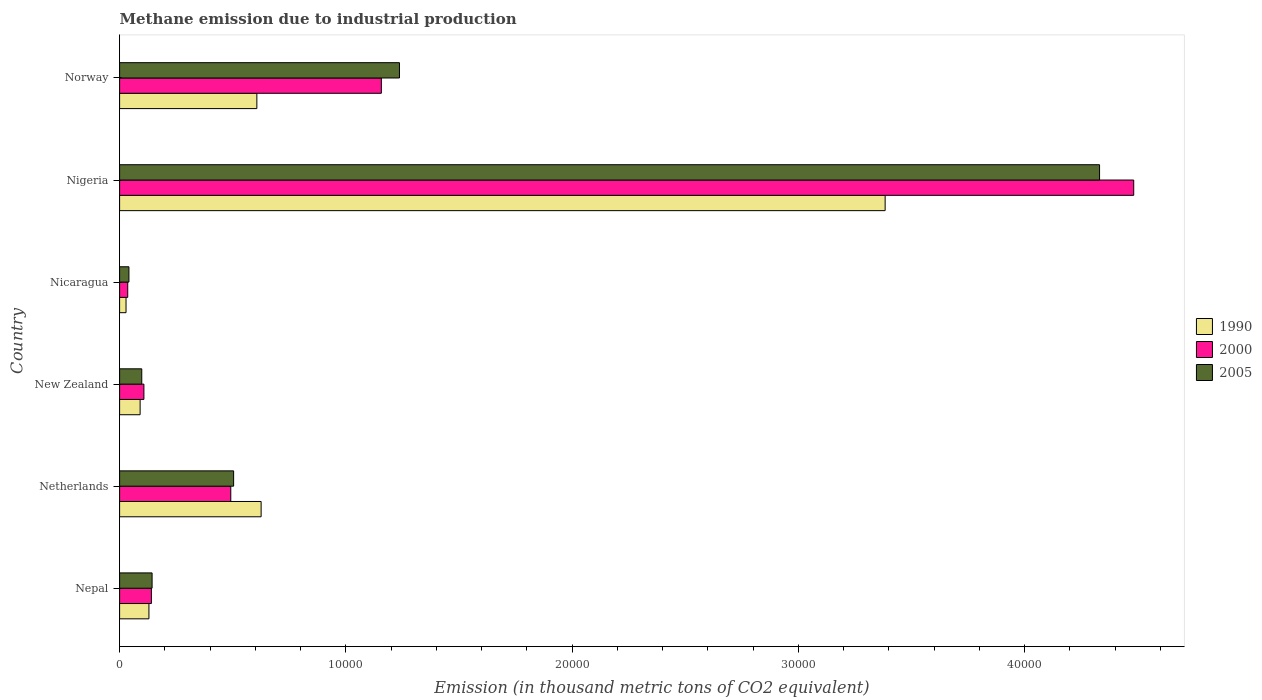How many different coloured bars are there?
Make the answer very short. 3. How many bars are there on the 5th tick from the top?
Offer a very short reply. 3. How many bars are there on the 2nd tick from the bottom?
Provide a short and direct response. 3. What is the label of the 5th group of bars from the top?
Make the answer very short. Netherlands. In how many cases, is the number of bars for a given country not equal to the number of legend labels?
Offer a terse response. 0. What is the amount of methane emitted in 2000 in Nicaragua?
Offer a very short reply. 359.5. Across all countries, what is the maximum amount of methane emitted in 2000?
Provide a succinct answer. 4.48e+04. Across all countries, what is the minimum amount of methane emitted in 2000?
Your answer should be very brief. 359.5. In which country was the amount of methane emitted in 2000 maximum?
Your answer should be very brief. Nigeria. In which country was the amount of methane emitted in 2000 minimum?
Make the answer very short. Nicaragua. What is the total amount of methane emitted in 1990 in the graph?
Your answer should be compact. 4.86e+04. What is the difference between the amount of methane emitted in 2000 in Nepal and that in Norway?
Provide a short and direct response. -1.02e+04. What is the difference between the amount of methane emitted in 1990 in Nicaragua and the amount of methane emitted in 2000 in Norway?
Provide a succinct answer. -1.13e+04. What is the average amount of methane emitted in 2000 per country?
Offer a terse response. 1.07e+04. What is the difference between the amount of methane emitted in 2000 and amount of methane emitted in 1990 in New Zealand?
Give a very brief answer. 167.2. In how many countries, is the amount of methane emitted in 1990 greater than 42000 thousand metric tons?
Offer a terse response. 0. What is the ratio of the amount of methane emitted in 2005 in Nepal to that in New Zealand?
Provide a succinct answer. 1.47. Is the amount of methane emitted in 1990 in Nicaragua less than that in Nigeria?
Give a very brief answer. Yes. Is the difference between the amount of methane emitted in 2000 in New Zealand and Nigeria greater than the difference between the amount of methane emitted in 1990 in New Zealand and Nigeria?
Provide a succinct answer. No. What is the difference between the highest and the second highest amount of methane emitted in 2005?
Your answer should be very brief. 3.09e+04. What is the difference between the highest and the lowest amount of methane emitted in 2000?
Provide a succinct answer. 4.45e+04. In how many countries, is the amount of methane emitted in 1990 greater than the average amount of methane emitted in 1990 taken over all countries?
Offer a terse response. 1. Is the sum of the amount of methane emitted in 1990 in Nepal and Nigeria greater than the maximum amount of methane emitted in 2000 across all countries?
Make the answer very short. No. Is it the case that in every country, the sum of the amount of methane emitted in 2000 and amount of methane emitted in 1990 is greater than the amount of methane emitted in 2005?
Your response must be concise. Yes. How many bars are there?
Give a very brief answer. 18. Are all the bars in the graph horizontal?
Keep it short and to the point. Yes. Are the values on the major ticks of X-axis written in scientific E-notation?
Provide a short and direct response. No. Does the graph contain any zero values?
Your answer should be very brief. No. Where does the legend appear in the graph?
Provide a short and direct response. Center right. How many legend labels are there?
Keep it short and to the point. 3. What is the title of the graph?
Ensure brevity in your answer.  Methane emission due to industrial production. What is the label or title of the X-axis?
Give a very brief answer. Emission (in thousand metric tons of CO2 equivalent). What is the Emission (in thousand metric tons of CO2 equivalent) in 1990 in Nepal?
Offer a very short reply. 1296.6. What is the Emission (in thousand metric tons of CO2 equivalent) in 2000 in Nepal?
Make the answer very short. 1405.1. What is the Emission (in thousand metric tons of CO2 equivalent) of 2005 in Nepal?
Provide a short and direct response. 1435.8. What is the Emission (in thousand metric tons of CO2 equivalent) of 1990 in Netherlands?
Make the answer very short. 6254.4. What is the Emission (in thousand metric tons of CO2 equivalent) in 2000 in Netherlands?
Ensure brevity in your answer.  4913.4. What is the Emission (in thousand metric tons of CO2 equivalent) in 2005 in Netherlands?
Keep it short and to the point. 5039.5. What is the Emission (in thousand metric tons of CO2 equivalent) of 1990 in New Zealand?
Your response must be concise. 906.8. What is the Emission (in thousand metric tons of CO2 equivalent) of 2000 in New Zealand?
Make the answer very short. 1074. What is the Emission (in thousand metric tons of CO2 equivalent) of 2005 in New Zealand?
Give a very brief answer. 979.4. What is the Emission (in thousand metric tons of CO2 equivalent) in 1990 in Nicaragua?
Ensure brevity in your answer.  284.1. What is the Emission (in thousand metric tons of CO2 equivalent) in 2000 in Nicaragua?
Your answer should be very brief. 359.5. What is the Emission (in thousand metric tons of CO2 equivalent) of 2005 in Nicaragua?
Make the answer very short. 412.7. What is the Emission (in thousand metric tons of CO2 equivalent) of 1990 in Nigeria?
Provide a succinct answer. 3.38e+04. What is the Emission (in thousand metric tons of CO2 equivalent) in 2000 in Nigeria?
Keep it short and to the point. 4.48e+04. What is the Emission (in thousand metric tons of CO2 equivalent) in 2005 in Nigeria?
Keep it short and to the point. 4.33e+04. What is the Emission (in thousand metric tons of CO2 equivalent) of 1990 in Norway?
Offer a terse response. 6065.9. What is the Emission (in thousand metric tons of CO2 equivalent) of 2000 in Norway?
Provide a short and direct response. 1.16e+04. What is the Emission (in thousand metric tons of CO2 equivalent) in 2005 in Norway?
Your response must be concise. 1.24e+04. Across all countries, what is the maximum Emission (in thousand metric tons of CO2 equivalent) of 1990?
Offer a terse response. 3.38e+04. Across all countries, what is the maximum Emission (in thousand metric tons of CO2 equivalent) in 2000?
Offer a terse response. 4.48e+04. Across all countries, what is the maximum Emission (in thousand metric tons of CO2 equivalent) of 2005?
Offer a terse response. 4.33e+04. Across all countries, what is the minimum Emission (in thousand metric tons of CO2 equivalent) of 1990?
Your answer should be compact. 284.1. Across all countries, what is the minimum Emission (in thousand metric tons of CO2 equivalent) in 2000?
Give a very brief answer. 359.5. Across all countries, what is the minimum Emission (in thousand metric tons of CO2 equivalent) in 2005?
Offer a very short reply. 412.7. What is the total Emission (in thousand metric tons of CO2 equivalent) of 1990 in the graph?
Offer a very short reply. 4.86e+04. What is the total Emission (in thousand metric tons of CO2 equivalent) of 2000 in the graph?
Provide a short and direct response. 6.41e+04. What is the total Emission (in thousand metric tons of CO2 equivalent) in 2005 in the graph?
Provide a succinct answer. 6.35e+04. What is the difference between the Emission (in thousand metric tons of CO2 equivalent) in 1990 in Nepal and that in Netherlands?
Keep it short and to the point. -4957.8. What is the difference between the Emission (in thousand metric tons of CO2 equivalent) in 2000 in Nepal and that in Netherlands?
Keep it short and to the point. -3508.3. What is the difference between the Emission (in thousand metric tons of CO2 equivalent) in 2005 in Nepal and that in Netherlands?
Provide a short and direct response. -3603.7. What is the difference between the Emission (in thousand metric tons of CO2 equivalent) of 1990 in Nepal and that in New Zealand?
Give a very brief answer. 389.8. What is the difference between the Emission (in thousand metric tons of CO2 equivalent) of 2000 in Nepal and that in New Zealand?
Your answer should be compact. 331.1. What is the difference between the Emission (in thousand metric tons of CO2 equivalent) of 2005 in Nepal and that in New Zealand?
Your answer should be very brief. 456.4. What is the difference between the Emission (in thousand metric tons of CO2 equivalent) of 1990 in Nepal and that in Nicaragua?
Give a very brief answer. 1012.5. What is the difference between the Emission (in thousand metric tons of CO2 equivalent) in 2000 in Nepal and that in Nicaragua?
Your answer should be very brief. 1045.6. What is the difference between the Emission (in thousand metric tons of CO2 equivalent) in 2005 in Nepal and that in Nicaragua?
Keep it short and to the point. 1023.1. What is the difference between the Emission (in thousand metric tons of CO2 equivalent) in 1990 in Nepal and that in Nigeria?
Offer a very short reply. -3.25e+04. What is the difference between the Emission (in thousand metric tons of CO2 equivalent) of 2000 in Nepal and that in Nigeria?
Provide a succinct answer. -4.34e+04. What is the difference between the Emission (in thousand metric tons of CO2 equivalent) of 2005 in Nepal and that in Nigeria?
Provide a short and direct response. -4.19e+04. What is the difference between the Emission (in thousand metric tons of CO2 equivalent) in 1990 in Nepal and that in Norway?
Provide a succinct answer. -4769.3. What is the difference between the Emission (in thousand metric tons of CO2 equivalent) of 2000 in Nepal and that in Norway?
Provide a short and direct response. -1.02e+04. What is the difference between the Emission (in thousand metric tons of CO2 equivalent) of 2005 in Nepal and that in Norway?
Your answer should be very brief. -1.09e+04. What is the difference between the Emission (in thousand metric tons of CO2 equivalent) in 1990 in Netherlands and that in New Zealand?
Provide a short and direct response. 5347.6. What is the difference between the Emission (in thousand metric tons of CO2 equivalent) of 2000 in Netherlands and that in New Zealand?
Ensure brevity in your answer.  3839.4. What is the difference between the Emission (in thousand metric tons of CO2 equivalent) of 2005 in Netherlands and that in New Zealand?
Provide a short and direct response. 4060.1. What is the difference between the Emission (in thousand metric tons of CO2 equivalent) in 1990 in Netherlands and that in Nicaragua?
Keep it short and to the point. 5970.3. What is the difference between the Emission (in thousand metric tons of CO2 equivalent) in 2000 in Netherlands and that in Nicaragua?
Your answer should be very brief. 4553.9. What is the difference between the Emission (in thousand metric tons of CO2 equivalent) in 2005 in Netherlands and that in Nicaragua?
Make the answer very short. 4626.8. What is the difference between the Emission (in thousand metric tons of CO2 equivalent) of 1990 in Netherlands and that in Nigeria?
Your answer should be very brief. -2.76e+04. What is the difference between the Emission (in thousand metric tons of CO2 equivalent) of 2000 in Netherlands and that in Nigeria?
Give a very brief answer. -3.99e+04. What is the difference between the Emission (in thousand metric tons of CO2 equivalent) in 2005 in Netherlands and that in Nigeria?
Offer a terse response. -3.83e+04. What is the difference between the Emission (in thousand metric tons of CO2 equivalent) of 1990 in Netherlands and that in Norway?
Ensure brevity in your answer.  188.5. What is the difference between the Emission (in thousand metric tons of CO2 equivalent) of 2000 in Netherlands and that in Norway?
Ensure brevity in your answer.  -6654.4. What is the difference between the Emission (in thousand metric tons of CO2 equivalent) in 2005 in Netherlands and that in Norway?
Your answer should be compact. -7329.3. What is the difference between the Emission (in thousand metric tons of CO2 equivalent) in 1990 in New Zealand and that in Nicaragua?
Your answer should be compact. 622.7. What is the difference between the Emission (in thousand metric tons of CO2 equivalent) of 2000 in New Zealand and that in Nicaragua?
Offer a very short reply. 714.5. What is the difference between the Emission (in thousand metric tons of CO2 equivalent) of 2005 in New Zealand and that in Nicaragua?
Provide a succinct answer. 566.7. What is the difference between the Emission (in thousand metric tons of CO2 equivalent) of 1990 in New Zealand and that in Nigeria?
Keep it short and to the point. -3.29e+04. What is the difference between the Emission (in thousand metric tons of CO2 equivalent) of 2000 in New Zealand and that in Nigeria?
Your answer should be compact. -4.37e+04. What is the difference between the Emission (in thousand metric tons of CO2 equivalent) of 2005 in New Zealand and that in Nigeria?
Make the answer very short. -4.23e+04. What is the difference between the Emission (in thousand metric tons of CO2 equivalent) in 1990 in New Zealand and that in Norway?
Offer a terse response. -5159.1. What is the difference between the Emission (in thousand metric tons of CO2 equivalent) in 2000 in New Zealand and that in Norway?
Your answer should be very brief. -1.05e+04. What is the difference between the Emission (in thousand metric tons of CO2 equivalent) in 2005 in New Zealand and that in Norway?
Offer a terse response. -1.14e+04. What is the difference between the Emission (in thousand metric tons of CO2 equivalent) of 1990 in Nicaragua and that in Nigeria?
Offer a terse response. -3.35e+04. What is the difference between the Emission (in thousand metric tons of CO2 equivalent) in 2000 in Nicaragua and that in Nigeria?
Offer a terse response. -4.45e+04. What is the difference between the Emission (in thousand metric tons of CO2 equivalent) of 2005 in Nicaragua and that in Nigeria?
Make the answer very short. -4.29e+04. What is the difference between the Emission (in thousand metric tons of CO2 equivalent) of 1990 in Nicaragua and that in Norway?
Provide a succinct answer. -5781.8. What is the difference between the Emission (in thousand metric tons of CO2 equivalent) in 2000 in Nicaragua and that in Norway?
Provide a short and direct response. -1.12e+04. What is the difference between the Emission (in thousand metric tons of CO2 equivalent) of 2005 in Nicaragua and that in Norway?
Make the answer very short. -1.20e+04. What is the difference between the Emission (in thousand metric tons of CO2 equivalent) in 1990 in Nigeria and that in Norway?
Keep it short and to the point. 2.78e+04. What is the difference between the Emission (in thousand metric tons of CO2 equivalent) of 2000 in Nigeria and that in Norway?
Provide a succinct answer. 3.33e+04. What is the difference between the Emission (in thousand metric tons of CO2 equivalent) in 2005 in Nigeria and that in Norway?
Ensure brevity in your answer.  3.09e+04. What is the difference between the Emission (in thousand metric tons of CO2 equivalent) of 1990 in Nepal and the Emission (in thousand metric tons of CO2 equivalent) of 2000 in Netherlands?
Offer a terse response. -3616.8. What is the difference between the Emission (in thousand metric tons of CO2 equivalent) in 1990 in Nepal and the Emission (in thousand metric tons of CO2 equivalent) in 2005 in Netherlands?
Offer a terse response. -3742.9. What is the difference between the Emission (in thousand metric tons of CO2 equivalent) in 2000 in Nepal and the Emission (in thousand metric tons of CO2 equivalent) in 2005 in Netherlands?
Offer a very short reply. -3634.4. What is the difference between the Emission (in thousand metric tons of CO2 equivalent) in 1990 in Nepal and the Emission (in thousand metric tons of CO2 equivalent) in 2000 in New Zealand?
Give a very brief answer. 222.6. What is the difference between the Emission (in thousand metric tons of CO2 equivalent) in 1990 in Nepal and the Emission (in thousand metric tons of CO2 equivalent) in 2005 in New Zealand?
Ensure brevity in your answer.  317.2. What is the difference between the Emission (in thousand metric tons of CO2 equivalent) in 2000 in Nepal and the Emission (in thousand metric tons of CO2 equivalent) in 2005 in New Zealand?
Your response must be concise. 425.7. What is the difference between the Emission (in thousand metric tons of CO2 equivalent) in 1990 in Nepal and the Emission (in thousand metric tons of CO2 equivalent) in 2000 in Nicaragua?
Offer a very short reply. 937.1. What is the difference between the Emission (in thousand metric tons of CO2 equivalent) of 1990 in Nepal and the Emission (in thousand metric tons of CO2 equivalent) of 2005 in Nicaragua?
Your response must be concise. 883.9. What is the difference between the Emission (in thousand metric tons of CO2 equivalent) of 2000 in Nepal and the Emission (in thousand metric tons of CO2 equivalent) of 2005 in Nicaragua?
Your answer should be compact. 992.4. What is the difference between the Emission (in thousand metric tons of CO2 equivalent) of 1990 in Nepal and the Emission (in thousand metric tons of CO2 equivalent) of 2000 in Nigeria?
Keep it short and to the point. -4.35e+04. What is the difference between the Emission (in thousand metric tons of CO2 equivalent) in 1990 in Nepal and the Emission (in thousand metric tons of CO2 equivalent) in 2005 in Nigeria?
Your response must be concise. -4.20e+04. What is the difference between the Emission (in thousand metric tons of CO2 equivalent) of 2000 in Nepal and the Emission (in thousand metric tons of CO2 equivalent) of 2005 in Nigeria?
Keep it short and to the point. -4.19e+04. What is the difference between the Emission (in thousand metric tons of CO2 equivalent) in 1990 in Nepal and the Emission (in thousand metric tons of CO2 equivalent) in 2000 in Norway?
Make the answer very short. -1.03e+04. What is the difference between the Emission (in thousand metric tons of CO2 equivalent) of 1990 in Nepal and the Emission (in thousand metric tons of CO2 equivalent) of 2005 in Norway?
Your response must be concise. -1.11e+04. What is the difference between the Emission (in thousand metric tons of CO2 equivalent) of 2000 in Nepal and the Emission (in thousand metric tons of CO2 equivalent) of 2005 in Norway?
Give a very brief answer. -1.10e+04. What is the difference between the Emission (in thousand metric tons of CO2 equivalent) in 1990 in Netherlands and the Emission (in thousand metric tons of CO2 equivalent) in 2000 in New Zealand?
Your response must be concise. 5180.4. What is the difference between the Emission (in thousand metric tons of CO2 equivalent) of 1990 in Netherlands and the Emission (in thousand metric tons of CO2 equivalent) of 2005 in New Zealand?
Provide a short and direct response. 5275. What is the difference between the Emission (in thousand metric tons of CO2 equivalent) of 2000 in Netherlands and the Emission (in thousand metric tons of CO2 equivalent) of 2005 in New Zealand?
Give a very brief answer. 3934. What is the difference between the Emission (in thousand metric tons of CO2 equivalent) of 1990 in Netherlands and the Emission (in thousand metric tons of CO2 equivalent) of 2000 in Nicaragua?
Your answer should be very brief. 5894.9. What is the difference between the Emission (in thousand metric tons of CO2 equivalent) of 1990 in Netherlands and the Emission (in thousand metric tons of CO2 equivalent) of 2005 in Nicaragua?
Ensure brevity in your answer.  5841.7. What is the difference between the Emission (in thousand metric tons of CO2 equivalent) of 2000 in Netherlands and the Emission (in thousand metric tons of CO2 equivalent) of 2005 in Nicaragua?
Your response must be concise. 4500.7. What is the difference between the Emission (in thousand metric tons of CO2 equivalent) in 1990 in Netherlands and the Emission (in thousand metric tons of CO2 equivalent) in 2000 in Nigeria?
Your answer should be very brief. -3.86e+04. What is the difference between the Emission (in thousand metric tons of CO2 equivalent) in 1990 in Netherlands and the Emission (in thousand metric tons of CO2 equivalent) in 2005 in Nigeria?
Make the answer very short. -3.71e+04. What is the difference between the Emission (in thousand metric tons of CO2 equivalent) in 2000 in Netherlands and the Emission (in thousand metric tons of CO2 equivalent) in 2005 in Nigeria?
Ensure brevity in your answer.  -3.84e+04. What is the difference between the Emission (in thousand metric tons of CO2 equivalent) of 1990 in Netherlands and the Emission (in thousand metric tons of CO2 equivalent) of 2000 in Norway?
Your answer should be very brief. -5313.4. What is the difference between the Emission (in thousand metric tons of CO2 equivalent) in 1990 in Netherlands and the Emission (in thousand metric tons of CO2 equivalent) in 2005 in Norway?
Your answer should be compact. -6114.4. What is the difference between the Emission (in thousand metric tons of CO2 equivalent) in 2000 in Netherlands and the Emission (in thousand metric tons of CO2 equivalent) in 2005 in Norway?
Keep it short and to the point. -7455.4. What is the difference between the Emission (in thousand metric tons of CO2 equivalent) in 1990 in New Zealand and the Emission (in thousand metric tons of CO2 equivalent) in 2000 in Nicaragua?
Give a very brief answer. 547.3. What is the difference between the Emission (in thousand metric tons of CO2 equivalent) of 1990 in New Zealand and the Emission (in thousand metric tons of CO2 equivalent) of 2005 in Nicaragua?
Offer a terse response. 494.1. What is the difference between the Emission (in thousand metric tons of CO2 equivalent) of 2000 in New Zealand and the Emission (in thousand metric tons of CO2 equivalent) of 2005 in Nicaragua?
Provide a succinct answer. 661.3. What is the difference between the Emission (in thousand metric tons of CO2 equivalent) of 1990 in New Zealand and the Emission (in thousand metric tons of CO2 equivalent) of 2000 in Nigeria?
Offer a very short reply. -4.39e+04. What is the difference between the Emission (in thousand metric tons of CO2 equivalent) of 1990 in New Zealand and the Emission (in thousand metric tons of CO2 equivalent) of 2005 in Nigeria?
Make the answer very short. -4.24e+04. What is the difference between the Emission (in thousand metric tons of CO2 equivalent) of 2000 in New Zealand and the Emission (in thousand metric tons of CO2 equivalent) of 2005 in Nigeria?
Your answer should be very brief. -4.22e+04. What is the difference between the Emission (in thousand metric tons of CO2 equivalent) of 1990 in New Zealand and the Emission (in thousand metric tons of CO2 equivalent) of 2000 in Norway?
Your response must be concise. -1.07e+04. What is the difference between the Emission (in thousand metric tons of CO2 equivalent) of 1990 in New Zealand and the Emission (in thousand metric tons of CO2 equivalent) of 2005 in Norway?
Keep it short and to the point. -1.15e+04. What is the difference between the Emission (in thousand metric tons of CO2 equivalent) in 2000 in New Zealand and the Emission (in thousand metric tons of CO2 equivalent) in 2005 in Norway?
Your answer should be very brief. -1.13e+04. What is the difference between the Emission (in thousand metric tons of CO2 equivalent) of 1990 in Nicaragua and the Emission (in thousand metric tons of CO2 equivalent) of 2000 in Nigeria?
Provide a short and direct response. -4.45e+04. What is the difference between the Emission (in thousand metric tons of CO2 equivalent) of 1990 in Nicaragua and the Emission (in thousand metric tons of CO2 equivalent) of 2005 in Nigeria?
Your answer should be compact. -4.30e+04. What is the difference between the Emission (in thousand metric tons of CO2 equivalent) of 2000 in Nicaragua and the Emission (in thousand metric tons of CO2 equivalent) of 2005 in Nigeria?
Provide a succinct answer. -4.30e+04. What is the difference between the Emission (in thousand metric tons of CO2 equivalent) in 1990 in Nicaragua and the Emission (in thousand metric tons of CO2 equivalent) in 2000 in Norway?
Offer a very short reply. -1.13e+04. What is the difference between the Emission (in thousand metric tons of CO2 equivalent) in 1990 in Nicaragua and the Emission (in thousand metric tons of CO2 equivalent) in 2005 in Norway?
Give a very brief answer. -1.21e+04. What is the difference between the Emission (in thousand metric tons of CO2 equivalent) of 2000 in Nicaragua and the Emission (in thousand metric tons of CO2 equivalent) of 2005 in Norway?
Offer a very short reply. -1.20e+04. What is the difference between the Emission (in thousand metric tons of CO2 equivalent) in 1990 in Nigeria and the Emission (in thousand metric tons of CO2 equivalent) in 2000 in Norway?
Make the answer very short. 2.23e+04. What is the difference between the Emission (in thousand metric tons of CO2 equivalent) in 1990 in Nigeria and the Emission (in thousand metric tons of CO2 equivalent) in 2005 in Norway?
Provide a short and direct response. 2.15e+04. What is the difference between the Emission (in thousand metric tons of CO2 equivalent) in 2000 in Nigeria and the Emission (in thousand metric tons of CO2 equivalent) in 2005 in Norway?
Your answer should be compact. 3.25e+04. What is the average Emission (in thousand metric tons of CO2 equivalent) of 1990 per country?
Make the answer very short. 8106.88. What is the average Emission (in thousand metric tons of CO2 equivalent) in 2000 per country?
Provide a short and direct response. 1.07e+04. What is the average Emission (in thousand metric tons of CO2 equivalent) in 2005 per country?
Your answer should be compact. 1.06e+04. What is the difference between the Emission (in thousand metric tons of CO2 equivalent) in 1990 and Emission (in thousand metric tons of CO2 equivalent) in 2000 in Nepal?
Provide a short and direct response. -108.5. What is the difference between the Emission (in thousand metric tons of CO2 equivalent) in 1990 and Emission (in thousand metric tons of CO2 equivalent) in 2005 in Nepal?
Provide a short and direct response. -139.2. What is the difference between the Emission (in thousand metric tons of CO2 equivalent) of 2000 and Emission (in thousand metric tons of CO2 equivalent) of 2005 in Nepal?
Keep it short and to the point. -30.7. What is the difference between the Emission (in thousand metric tons of CO2 equivalent) in 1990 and Emission (in thousand metric tons of CO2 equivalent) in 2000 in Netherlands?
Provide a succinct answer. 1341. What is the difference between the Emission (in thousand metric tons of CO2 equivalent) of 1990 and Emission (in thousand metric tons of CO2 equivalent) of 2005 in Netherlands?
Offer a terse response. 1214.9. What is the difference between the Emission (in thousand metric tons of CO2 equivalent) in 2000 and Emission (in thousand metric tons of CO2 equivalent) in 2005 in Netherlands?
Give a very brief answer. -126.1. What is the difference between the Emission (in thousand metric tons of CO2 equivalent) in 1990 and Emission (in thousand metric tons of CO2 equivalent) in 2000 in New Zealand?
Provide a short and direct response. -167.2. What is the difference between the Emission (in thousand metric tons of CO2 equivalent) in 1990 and Emission (in thousand metric tons of CO2 equivalent) in 2005 in New Zealand?
Ensure brevity in your answer.  -72.6. What is the difference between the Emission (in thousand metric tons of CO2 equivalent) in 2000 and Emission (in thousand metric tons of CO2 equivalent) in 2005 in New Zealand?
Keep it short and to the point. 94.6. What is the difference between the Emission (in thousand metric tons of CO2 equivalent) in 1990 and Emission (in thousand metric tons of CO2 equivalent) in 2000 in Nicaragua?
Make the answer very short. -75.4. What is the difference between the Emission (in thousand metric tons of CO2 equivalent) in 1990 and Emission (in thousand metric tons of CO2 equivalent) in 2005 in Nicaragua?
Your response must be concise. -128.6. What is the difference between the Emission (in thousand metric tons of CO2 equivalent) of 2000 and Emission (in thousand metric tons of CO2 equivalent) of 2005 in Nicaragua?
Provide a succinct answer. -53.2. What is the difference between the Emission (in thousand metric tons of CO2 equivalent) of 1990 and Emission (in thousand metric tons of CO2 equivalent) of 2000 in Nigeria?
Make the answer very short. -1.10e+04. What is the difference between the Emission (in thousand metric tons of CO2 equivalent) of 1990 and Emission (in thousand metric tons of CO2 equivalent) of 2005 in Nigeria?
Your answer should be very brief. -9476.4. What is the difference between the Emission (in thousand metric tons of CO2 equivalent) in 2000 and Emission (in thousand metric tons of CO2 equivalent) in 2005 in Nigeria?
Provide a short and direct response. 1509.9. What is the difference between the Emission (in thousand metric tons of CO2 equivalent) in 1990 and Emission (in thousand metric tons of CO2 equivalent) in 2000 in Norway?
Offer a very short reply. -5501.9. What is the difference between the Emission (in thousand metric tons of CO2 equivalent) of 1990 and Emission (in thousand metric tons of CO2 equivalent) of 2005 in Norway?
Give a very brief answer. -6302.9. What is the difference between the Emission (in thousand metric tons of CO2 equivalent) of 2000 and Emission (in thousand metric tons of CO2 equivalent) of 2005 in Norway?
Your response must be concise. -801. What is the ratio of the Emission (in thousand metric tons of CO2 equivalent) in 1990 in Nepal to that in Netherlands?
Give a very brief answer. 0.21. What is the ratio of the Emission (in thousand metric tons of CO2 equivalent) in 2000 in Nepal to that in Netherlands?
Offer a very short reply. 0.29. What is the ratio of the Emission (in thousand metric tons of CO2 equivalent) in 2005 in Nepal to that in Netherlands?
Your answer should be very brief. 0.28. What is the ratio of the Emission (in thousand metric tons of CO2 equivalent) in 1990 in Nepal to that in New Zealand?
Your answer should be compact. 1.43. What is the ratio of the Emission (in thousand metric tons of CO2 equivalent) in 2000 in Nepal to that in New Zealand?
Offer a very short reply. 1.31. What is the ratio of the Emission (in thousand metric tons of CO2 equivalent) of 2005 in Nepal to that in New Zealand?
Your answer should be compact. 1.47. What is the ratio of the Emission (in thousand metric tons of CO2 equivalent) of 1990 in Nepal to that in Nicaragua?
Provide a short and direct response. 4.56. What is the ratio of the Emission (in thousand metric tons of CO2 equivalent) in 2000 in Nepal to that in Nicaragua?
Provide a succinct answer. 3.91. What is the ratio of the Emission (in thousand metric tons of CO2 equivalent) in 2005 in Nepal to that in Nicaragua?
Your response must be concise. 3.48. What is the ratio of the Emission (in thousand metric tons of CO2 equivalent) in 1990 in Nepal to that in Nigeria?
Offer a terse response. 0.04. What is the ratio of the Emission (in thousand metric tons of CO2 equivalent) in 2000 in Nepal to that in Nigeria?
Your answer should be compact. 0.03. What is the ratio of the Emission (in thousand metric tons of CO2 equivalent) in 2005 in Nepal to that in Nigeria?
Offer a very short reply. 0.03. What is the ratio of the Emission (in thousand metric tons of CO2 equivalent) in 1990 in Nepal to that in Norway?
Keep it short and to the point. 0.21. What is the ratio of the Emission (in thousand metric tons of CO2 equivalent) in 2000 in Nepal to that in Norway?
Make the answer very short. 0.12. What is the ratio of the Emission (in thousand metric tons of CO2 equivalent) of 2005 in Nepal to that in Norway?
Keep it short and to the point. 0.12. What is the ratio of the Emission (in thousand metric tons of CO2 equivalent) of 1990 in Netherlands to that in New Zealand?
Make the answer very short. 6.9. What is the ratio of the Emission (in thousand metric tons of CO2 equivalent) in 2000 in Netherlands to that in New Zealand?
Your answer should be compact. 4.57. What is the ratio of the Emission (in thousand metric tons of CO2 equivalent) in 2005 in Netherlands to that in New Zealand?
Provide a succinct answer. 5.15. What is the ratio of the Emission (in thousand metric tons of CO2 equivalent) in 1990 in Netherlands to that in Nicaragua?
Keep it short and to the point. 22.01. What is the ratio of the Emission (in thousand metric tons of CO2 equivalent) in 2000 in Netherlands to that in Nicaragua?
Ensure brevity in your answer.  13.67. What is the ratio of the Emission (in thousand metric tons of CO2 equivalent) in 2005 in Netherlands to that in Nicaragua?
Provide a succinct answer. 12.21. What is the ratio of the Emission (in thousand metric tons of CO2 equivalent) in 1990 in Netherlands to that in Nigeria?
Your answer should be very brief. 0.18. What is the ratio of the Emission (in thousand metric tons of CO2 equivalent) in 2000 in Netherlands to that in Nigeria?
Offer a very short reply. 0.11. What is the ratio of the Emission (in thousand metric tons of CO2 equivalent) of 2005 in Netherlands to that in Nigeria?
Offer a very short reply. 0.12. What is the ratio of the Emission (in thousand metric tons of CO2 equivalent) in 1990 in Netherlands to that in Norway?
Your answer should be compact. 1.03. What is the ratio of the Emission (in thousand metric tons of CO2 equivalent) in 2000 in Netherlands to that in Norway?
Ensure brevity in your answer.  0.42. What is the ratio of the Emission (in thousand metric tons of CO2 equivalent) of 2005 in Netherlands to that in Norway?
Ensure brevity in your answer.  0.41. What is the ratio of the Emission (in thousand metric tons of CO2 equivalent) of 1990 in New Zealand to that in Nicaragua?
Offer a very short reply. 3.19. What is the ratio of the Emission (in thousand metric tons of CO2 equivalent) in 2000 in New Zealand to that in Nicaragua?
Your answer should be very brief. 2.99. What is the ratio of the Emission (in thousand metric tons of CO2 equivalent) of 2005 in New Zealand to that in Nicaragua?
Ensure brevity in your answer.  2.37. What is the ratio of the Emission (in thousand metric tons of CO2 equivalent) in 1990 in New Zealand to that in Nigeria?
Keep it short and to the point. 0.03. What is the ratio of the Emission (in thousand metric tons of CO2 equivalent) of 2000 in New Zealand to that in Nigeria?
Give a very brief answer. 0.02. What is the ratio of the Emission (in thousand metric tons of CO2 equivalent) in 2005 in New Zealand to that in Nigeria?
Ensure brevity in your answer.  0.02. What is the ratio of the Emission (in thousand metric tons of CO2 equivalent) of 1990 in New Zealand to that in Norway?
Your answer should be very brief. 0.15. What is the ratio of the Emission (in thousand metric tons of CO2 equivalent) of 2000 in New Zealand to that in Norway?
Your answer should be compact. 0.09. What is the ratio of the Emission (in thousand metric tons of CO2 equivalent) of 2005 in New Zealand to that in Norway?
Keep it short and to the point. 0.08. What is the ratio of the Emission (in thousand metric tons of CO2 equivalent) in 1990 in Nicaragua to that in Nigeria?
Give a very brief answer. 0.01. What is the ratio of the Emission (in thousand metric tons of CO2 equivalent) in 2000 in Nicaragua to that in Nigeria?
Your answer should be very brief. 0.01. What is the ratio of the Emission (in thousand metric tons of CO2 equivalent) in 2005 in Nicaragua to that in Nigeria?
Give a very brief answer. 0.01. What is the ratio of the Emission (in thousand metric tons of CO2 equivalent) in 1990 in Nicaragua to that in Norway?
Keep it short and to the point. 0.05. What is the ratio of the Emission (in thousand metric tons of CO2 equivalent) in 2000 in Nicaragua to that in Norway?
Ensure brevity in your answer.  0.03. What is the ratio of the Emission (in thousand metric tons of CO2 equivalent) of 2005 in Nicaragua to that in Norway?
Ensure brevity in your answer.  0.03. What is the ratio of the Emission (in thousand metric tons of CO2 equivalent) of 1990 in Nigeria to that in Norway?
Make the answer very short. 5.58. What is the ratio of the Emission (in thousand metric tons of CO2 equivalent) of 2000 in Nigeria to that in Norway?
Ensure brevity in your answer.  3.87. What is the ratio of the Emission (in thousand metric tons of CO2 equivalent) of 2005 in Nigeria to that in Norway?
Provide a succinct answer. 3.5. What is the difference between the highest and the second highest Emission (in thousand metric tons of CO2 equivalent) of 1990?
Make the answer very short. 2.76e+04. What is the difference between the highest and the second highest Emission (in thousand metric tons of CO2 equivalent) in 2000?
Give a very brief answer. 3.33e+04. What is the difference between the highest and the second highest Emission (in thousand metric tons of CO2 equivalent) in 2005?
Offer a terse response. 3.09e+04. What is the difference between the highest and the lowest Emission (in thousand metric tons of CO2 equivalent) in 1990?
Your response must be concise. 3.35e+04. What is the difference between the highest and the lowest Emission (in thousand metric tons of CO2 equivalent) of 2000?
Make the answer very short. 4.45e+04. What is the difference between the highest and the lowest Emission (in thousand metric tons of CO2 equivalent) in 2005?
Offer a terse response. 4.29e+04. 